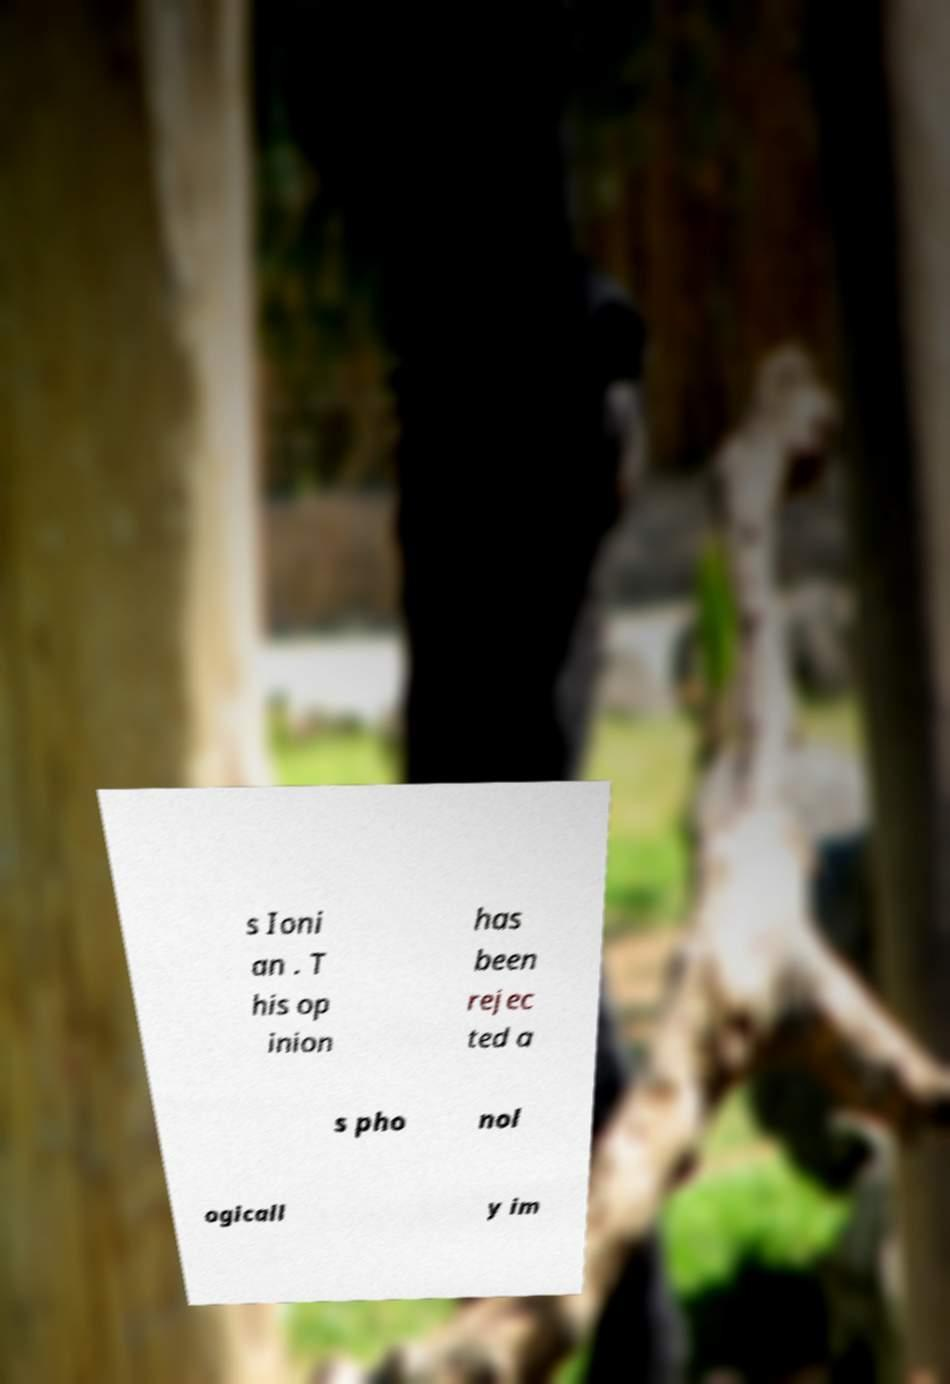For documentation purposes, I need the text within this image transcribed. Could you provide that? s Ioni an . T his op inion has been rejec ted a s pho nol ogicall y im 